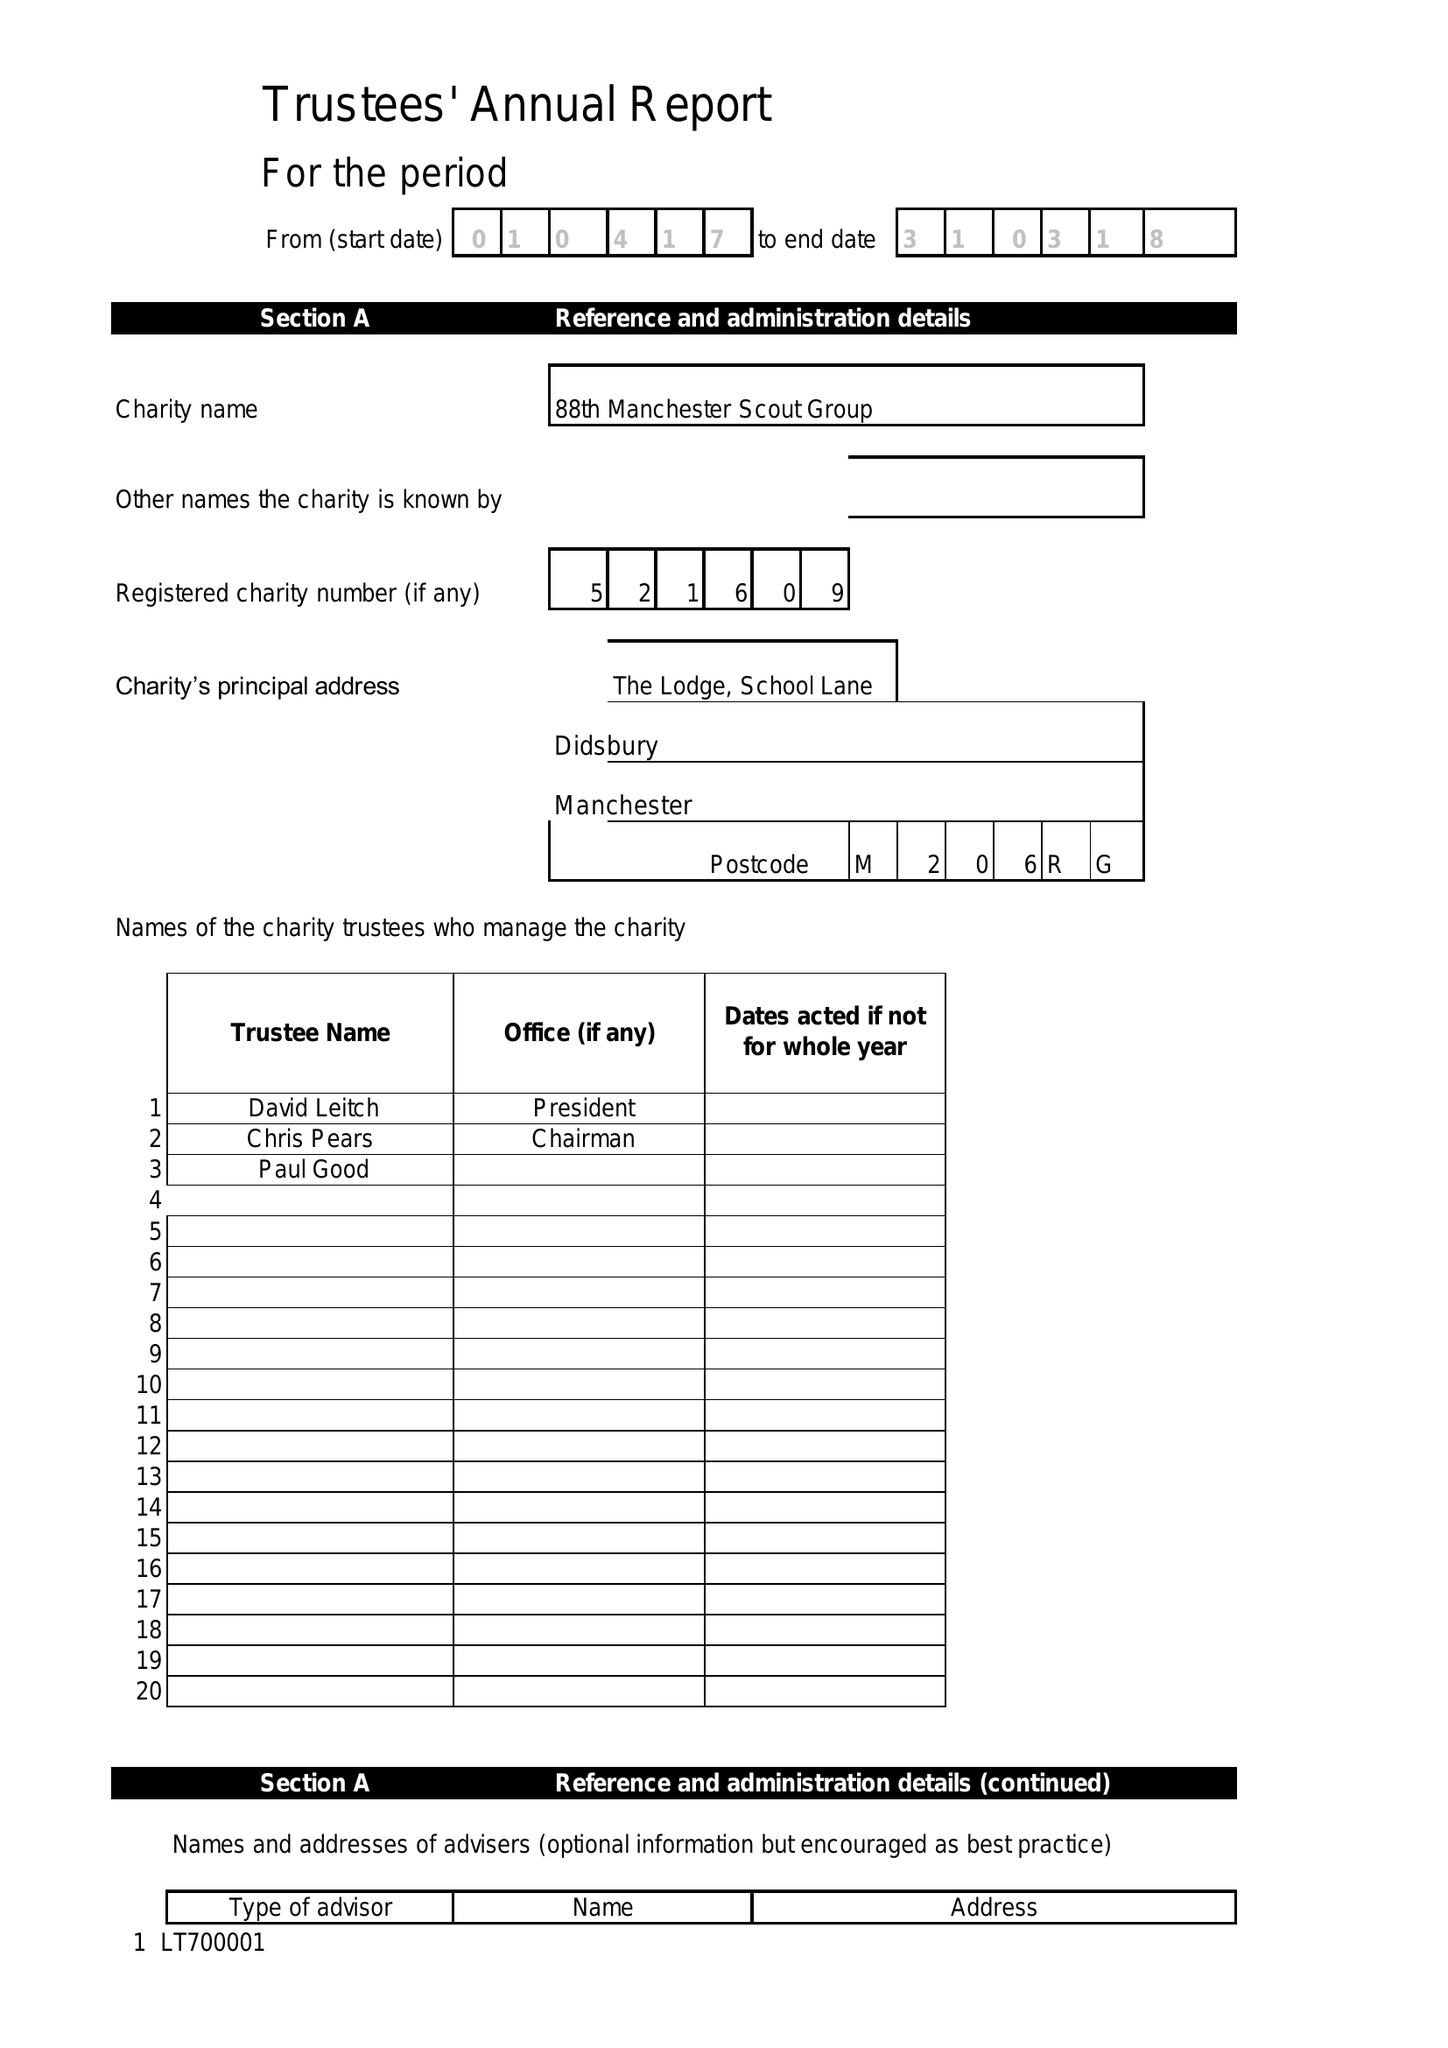What is the value for the report_date?
Answer the question using a single word or phrase. 2017-03-30 